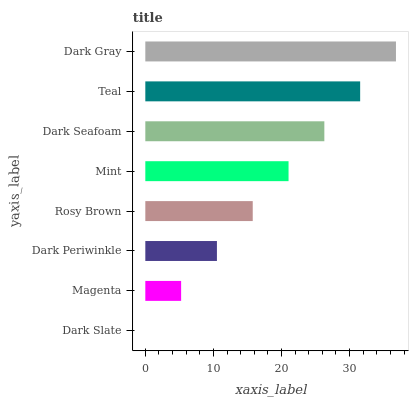Is Dark Slate the minimum?
Answer yes or no. Yes. Is Dark Gray the maximum?
Answer yes or no. Yes. Is Magenta the minimum?
Answer yes or no. No. Is Magenta the maximum?
Answer yes or no. No. Is Magenta greater than Dark Slate?
Answer yes or no. Yes. Is Dark Slate less than Magenta?
Answer yes or no. Yes. Is Dark Slate greater than Magenta?
Answer yes or no. No. Is Magenta less than Dark Slate?
Answer yes or no. No. Is Mint the high median?
Answer yes or no. Yes. Is Rosy Brown the low median?
Answer yes or no. Yes. Is Dark Gray the high median?
Answer yes or no. No. Is Dark Periwinkle the low median?
Answer yes or no. No. 